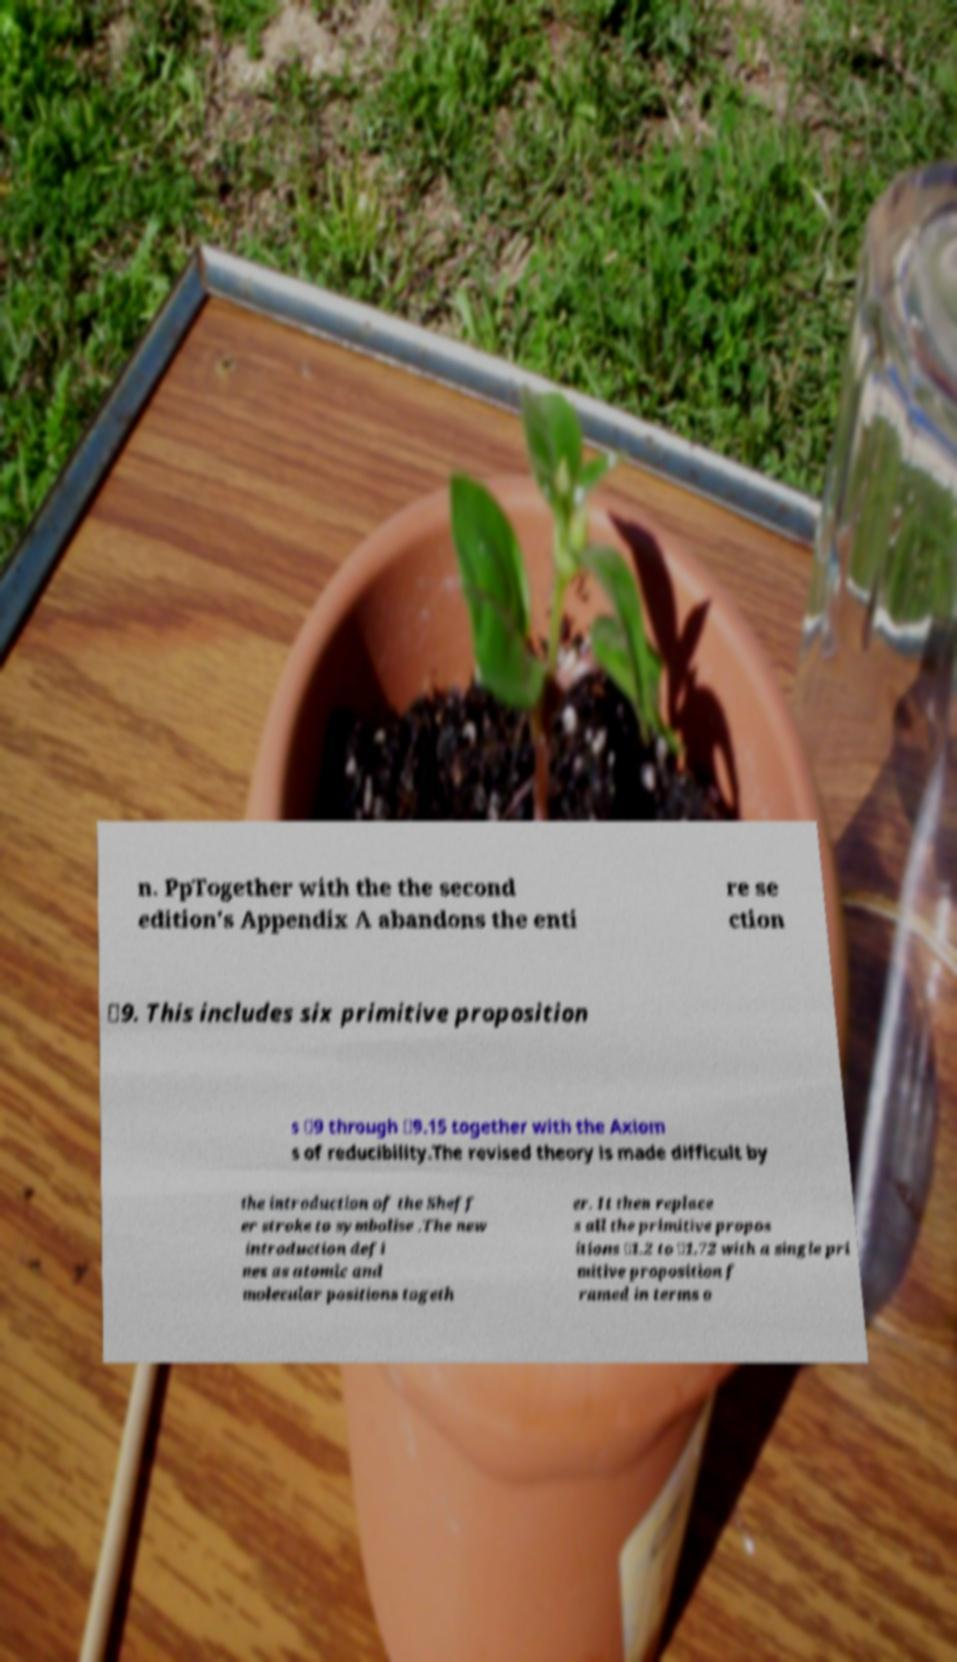There's text embedded in this image that I need extracted. Can you transcribe it verbatim? n. PpTogether with the the second edition's Appendix A abandons the enti re se ction ✸9. This includes six primitive proposition s ✸9 through ✸9.15 together with the Axiom s of reducibility.The revised theory is made difficult by the introduction of the Sheff er stroke to symbolise .The new introduction defi nes as atomic and molecular positions togeth er. It then replace s all the primitive propos itions ✸1.2 to ✸1.72 with a single pri mitive proposition f ramed in terms o 